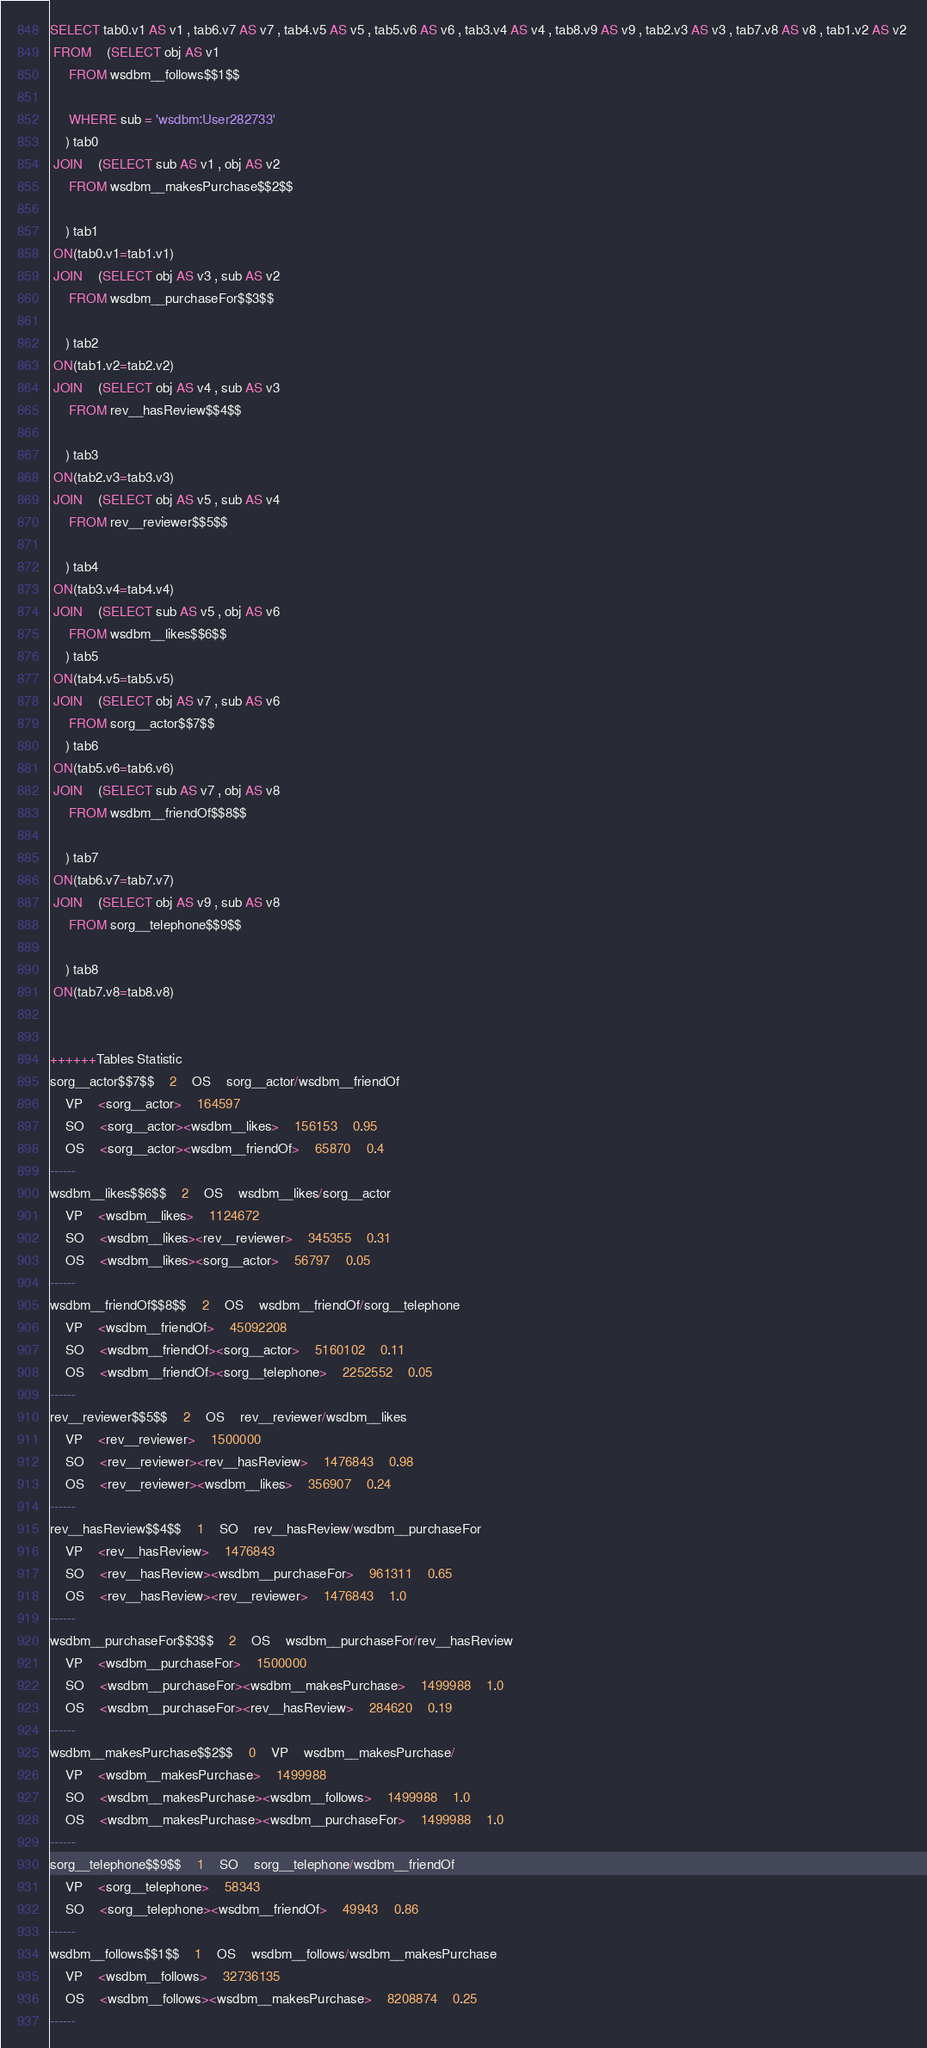<code> <loc_0><loc_0><loc_500><loc_500><_SQL_>SELECT tab0.v1 AS v1 , tab6.v7 AS v7 , tab4.v5 AS v5 , tab5.v6 AS v6 , tab3.v4 AS v4 , tab8.v9 AS v9 , tab2.v3 AS v3 , tab7.v8 AS v8 , tab1.v2 AS v2 
 FROM    (SELECT obj AS v1 
	 FROM wsdbm__follows$$1$$
	 
	 WHERE sub = 'wsdbm:User282733'
	) tab0
 JOIN    (SELECT sub AS v1 , obj AS v2 
	 FROM wsdbm__makesPurchase$$2$$
	
	) tab1
 ON(tab0.v1=tab1.v1)
 JOIN    (SELECT obj AS v3 , sub AS v2 
	 FROM wsdbm__purchaseFor$$3$$
	
	) tab2
 ON(tab1.v2=tab2.v2)
 JOIN    (SELECT obj AS v4 , sub AS v3 
	 FROM rev__hasReview$$4$$
	
	) tab3
 ON(tab2.v3=tab3.v3)
 JOIN    (SELECT obj AS v5 , sub AS v4 
	 FROM rev__reviewer$$5$$
	
	) tab4
 ON(tab3.v4=tab4.v4)
 JOIN    (SELECT sub AS v5 , obj AS v6 
	 FROM wsdbm__likes$$6$$
	) tab5
 ON(tab4.v5=tab5.v5)
 JOIN    (SELECT obj AS v7 , sub AS v6 
	 FROM sorg__actor$$7$$
	) tab6
 ON(tab5.v6=tab6.v6)
 JOIN    (SELECT sub AS v7 , obj AS v8 
	 FROM wsdbm__friendOf$$8$$
	
	) tab7
 ON(tab6.v7=tab7.v7)
 JOIN    (SELECT obj AS v9 , sub AS v8 
	 FROM sorg__telephone$$9$$
	
	) tab8
 ON(tab7.v8=tab8.v8)


++++++Tables Statistic
sorg__actor$$7$$	2	OS	sorg__actor/wsdbm__friendOf
	VP	<sorg__actor>	164597
	SO	<sorg__actor><wsdbm__likes>	156153	0.95
	OS	<sorg__actor><wsdbm__friendOf>	65870	0.4
------
wsdbm__likes$$6$$	2	OS	wsdbm__likes/sorg__actor
	VP	<wsdbm__likes>	1124672
	SO	<wsdbm__likes><rev__reviewer>	345355	0.31
	OS	<wsdbm__likes><sorg__actor>	56797	0.05
------
wsdbm__friendOf$$8$$	2	OS	wsdbm__friendOf/sorg__telephone
	VP	<wsdbm__friendOf>	45092208
	SO	<wsdbm__friendOf><sorg__actor>	5160102	0.11
	OS	<wsdbm__friendOf><sorg__telephone>	2252552	0.05
------
rev__reviewer$$5$$	2	OS	rev__reviewer/wsdbm__likes
	VP	<rev__reviewer>	1500000
	SO	<rev__reviewer><rev__hasReview>	1476843	0.98
	OS	<rev__reviewer><wsdbm__likes>	356907	0.24
------
rev__hasReview$$4$$	1	SO	rev__hasReview/wsdbm__purchaseFor
	VP	<rev__hasReview>	1476843
	SO	<rev__hasReview><wsdbm__purchaseFor>	961311	0.65
	OS	<rev__hasReview><rev__reviewer>	1476843	1.0
------
wsdbm__purchaseFor$$3$$	2	OS	wsdbm__purchaseFor/rev__hasReview
	VP	<wsdbm__purchaseFor>	1500000
	SO	<wsdbm__purchaseFor><wsdbm__makesPurchase>	1499988	1.0
	OS	<wsdbm__purchaseFor><rev__hasReview>	284620	0.19
------
wsdbm__makesPurchase$$2$$	0	VP	wsdbm__makesPurchase/
	VP	<wsdbm__makesPurchase>	1499988
	SO	<wsdbm__makesPurchase><wsdbm__follows>	1499988	1.0
	OS	<wsdbm__makesPurchase><wsdbm__purchaseFor>	1499988	1.0
------
sorg__telephone$$9$$	1	SO	sorg__telephone/wsdbm__friendOf
	VP	<sorg__telephone>	58343
	SO	<sorg__telephone><wsdbm__friendOf>	49943	0.86
------
wsdbm__follows$$1$$	1	OS	wsdbm__follows/wsdbm__makesPurchase
	VP	<wsdbm__follows>	32736135
	OS	<wsdbm__follows><wsdbm__makesPurchase>	8208874	0.25
------
</code> 